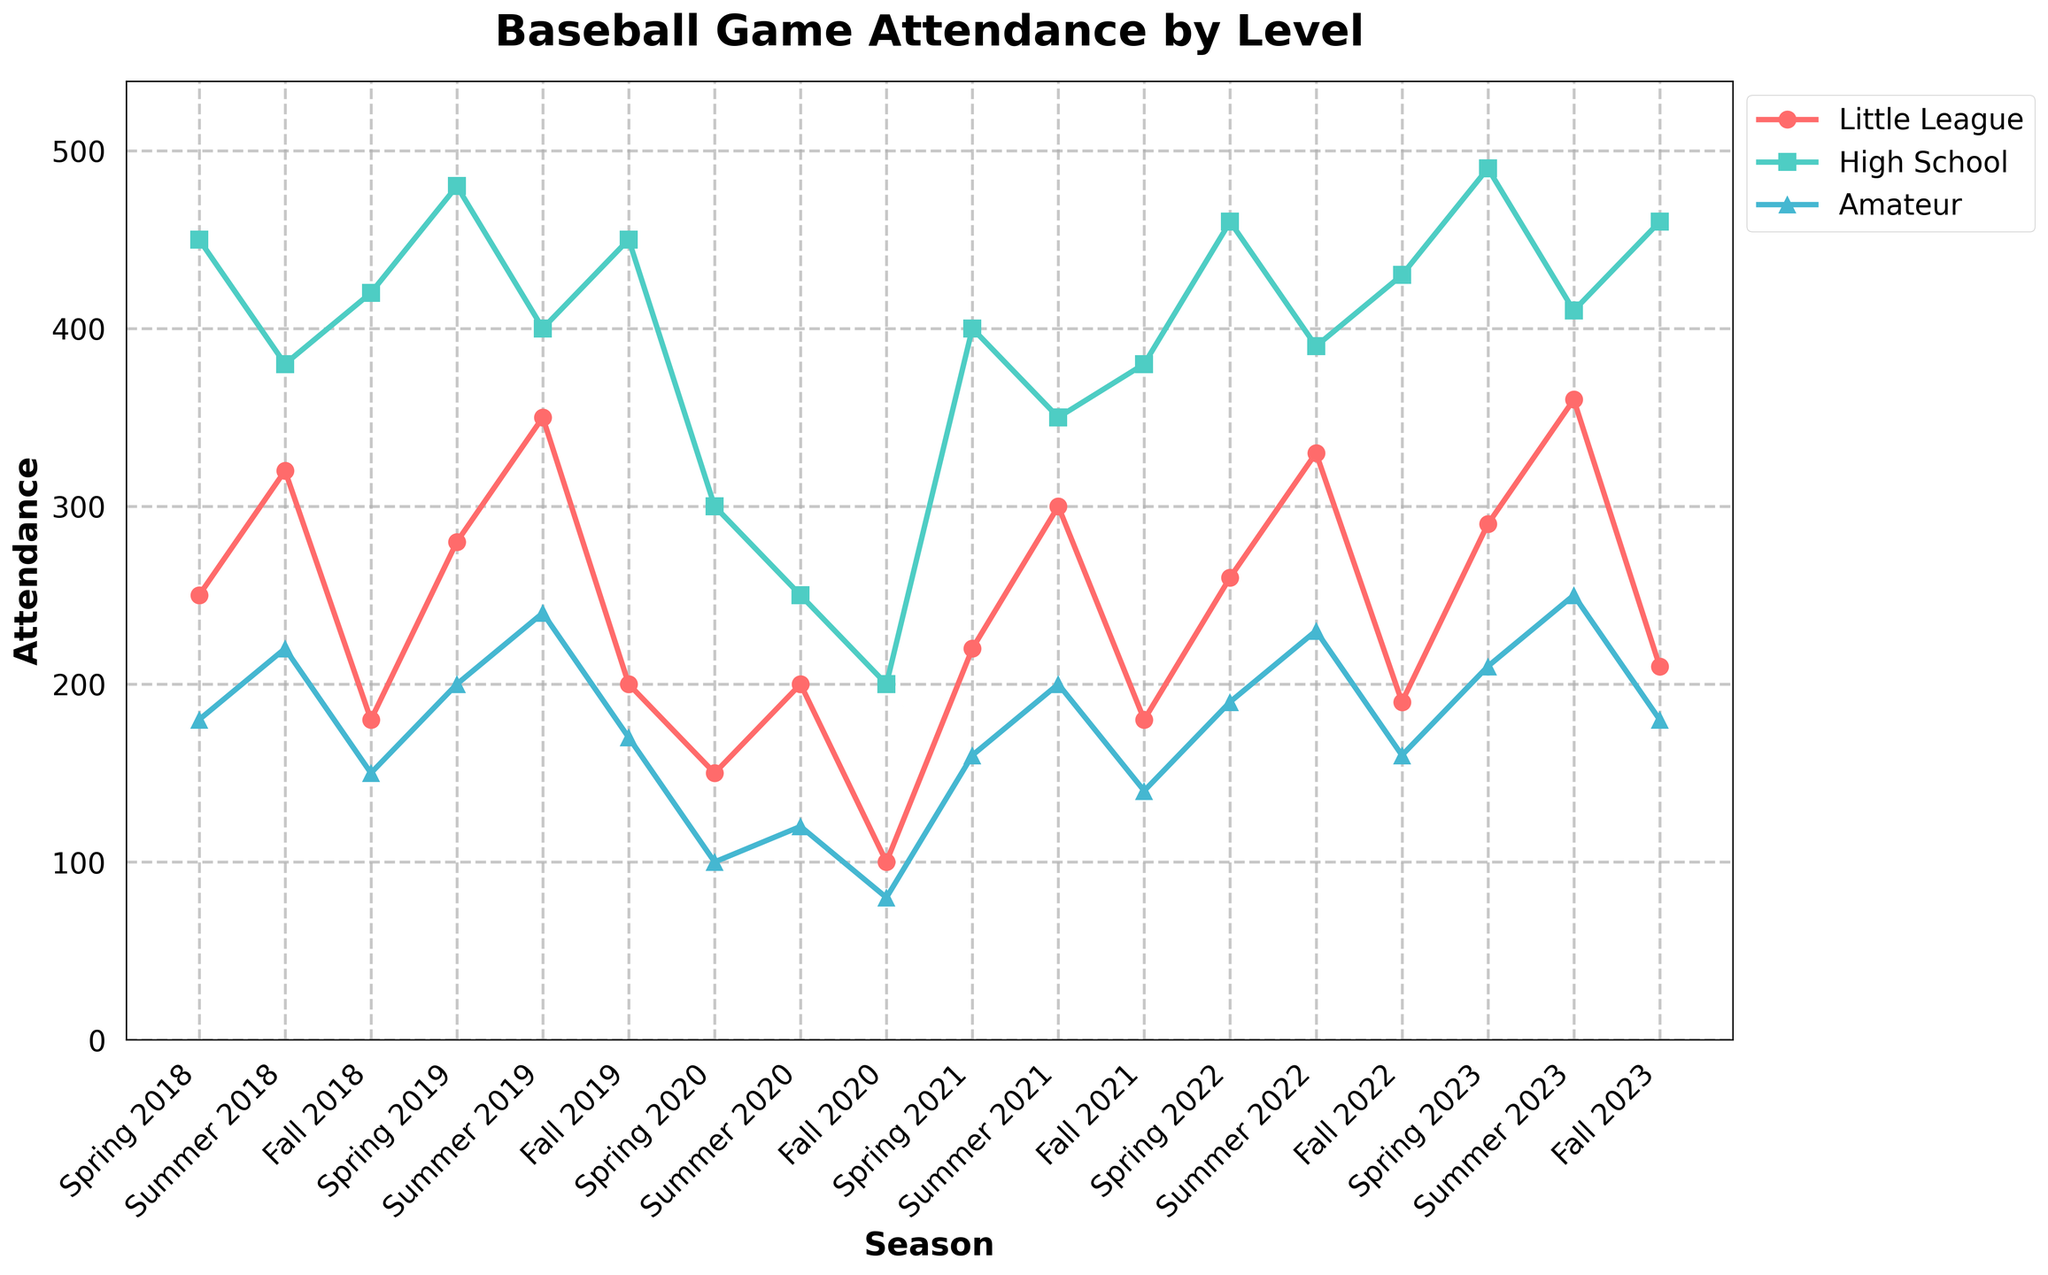Which season had the highest attendance for High School games? First, identify the "High School" line in the plot, which is colored green. Then, find the peak point in this line by looking for the highest value. The highest value appears in Spring 2023.
Answer: Spring 2023 What is the difference in attendance between Little League and Amateur in Summer 2019? Locate the points for "Little League" and "Amateur" in the Summer 2019 season on the plot. The attendance for Little League is 350 and for Amateur is 240. Calculate the difference: 350 - 240 = 110.
Answer: 110 In which season did Little League attendance drop to its lowest value? To find the lowest attendance for Little League, locate the red line and find the lowest point. The lowest value occurs in Fall 2020.
Answer: Fall 2020 What is the average attendance for High School games across all Fall seasons from 2018 to 2023? First, identify the High School attendance values for Fall 2018, Fall 2019, Fall 2020, Fall 2021, Fall 2022, and Fall 2023. These values are 420, 450, 200, 380, 430, and 460 respectively. Sum these values: 420 + 450 + 200 + 380 + 430 + 460 = 2340. Then, divide by the number of seasons (6): 2340 / 6 = 390.
Answer: 390 How did Amateur attendance change from Spring 2020 to Fall 2020 and then to Spring 2021? First, find the attendance values for Amateur in Spring 2020, Fall 2020, and Spring 2021. These values are 100, 80, and 160 respectively. Calculate the changes: Fall 2020 - Spring 2020 is 80 - 100 = -20 (a decrease), and Spring 2021 - Fall 2020 is 160 - 80 = 80 (an increase).
Answer: Decrease by 20 and then increase by 80 Which level had the smallest attendance variance over the given seasons? To determine the smallest variance, look at the variations in the lines for Little League, High School, and Amateur. The Little League and High School lines show significant fluctuations, whereas the Amateur line shows relatively smaller fluctuations. Therefore, Amateur had the smallest variance.
Answer: Amateur Compare the attendance trends for Little League and High School between Spring and Summer of 2023. Identify the attendance values for both levels in Spring and Summer of 2023. Little League values: Spring 2023 is 290, Summer 2023 is 360. High School values: Spring 2023 is 490, Summer 2023 is 410. Little League increased by 70 (360 - 290), whereas High School decreased by 80 (410 - 490).
Answer: Little League increased, High School decreased In which season did Amateur attendance first exceed 200? To find the first season when Amateur attendance exceeded 200, identify the points on the blue line where the value is greater than 200. The first such occurrence is Summer 2018 with an attendance of 220.
Answer: Summer 2018 What is the total attendance for High School games in Spring seasons from 2018 to 2023? First, identify the High School attendance values for Spring 2018, Spring 2019, Spring 2020, Spring 2021, Spring 2022, and Spring 2023. These values are 450, 480, 300, 400, 460, and 490 respectively. Sum these values: 450 + 480 + 300 + 400 + 460 + 490 = 2580.
Answer: 2580 